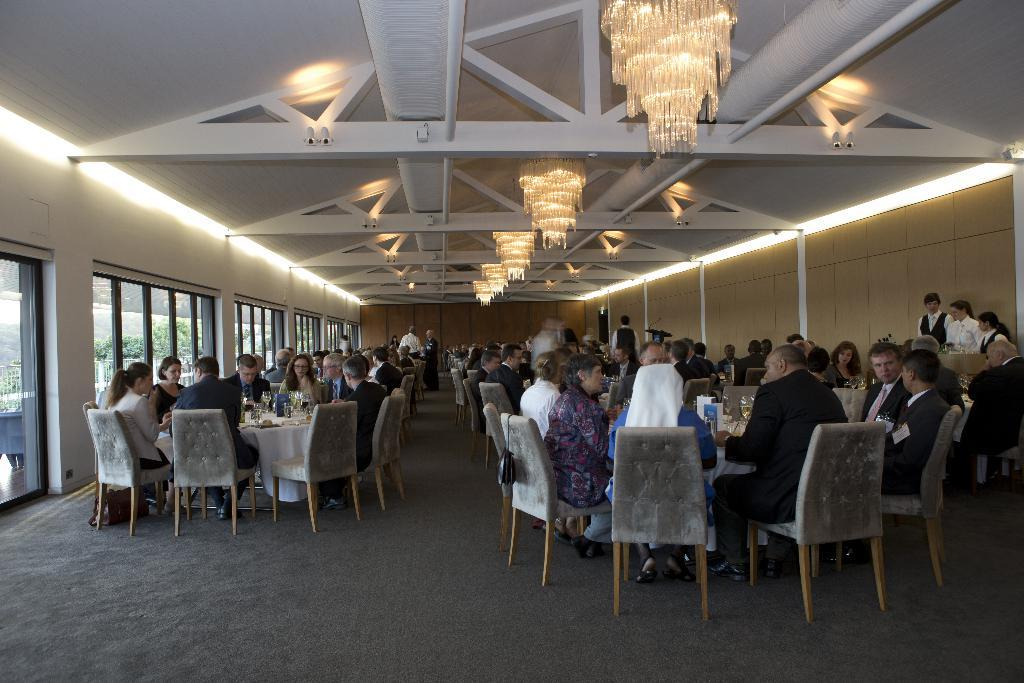What type of location is shown in the image? The image depicts a dining hall. What are the people in the image doing? The people are present in the dining hall and are having their meal. What type of lighting is visible in the image? Chandeliers are visible at the top of the image. Where are the doors located in the image? The doors are in the left side of the image. What type of vegetation is present in the image? Greenery is present in the image. What type of cushion is being used to record the rain in the image? There is no cushion or rain present in the image; it depicts a dining hall with people having their meal. 